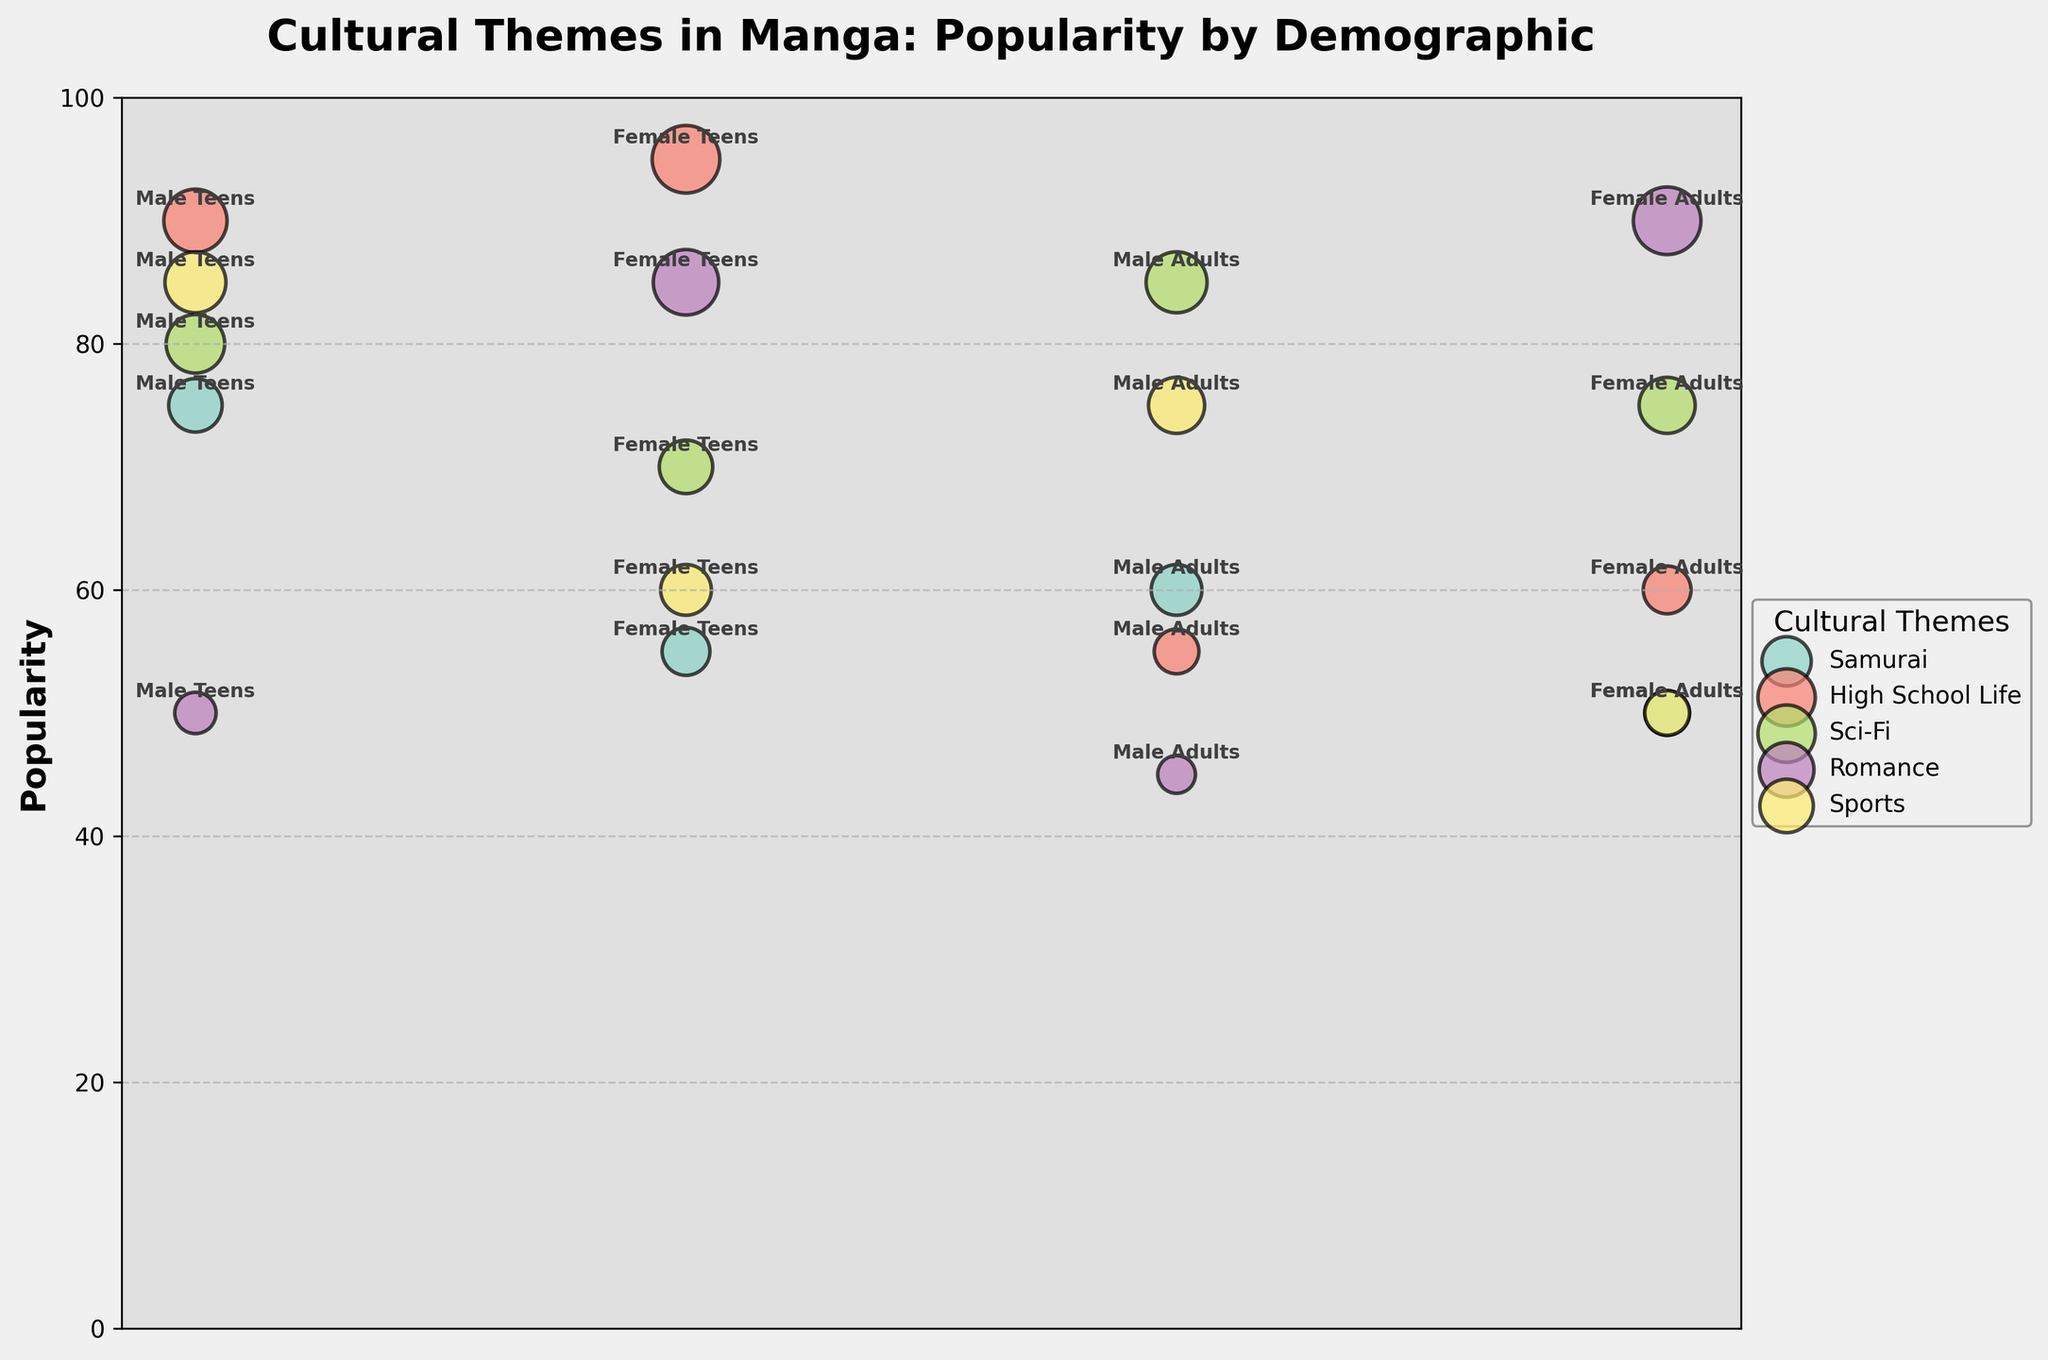What's the most popular theme among Female Teens? From the plot, we can look at the y-axis, which represents popularity, and compare the points labeled "Female Teens". The point with the highest y-value indicates the most popular theme for Female Teens. In this case, it's "High School Life" with a popularity score of 95.
Answer: High School Life Which demographic segment finds Romance the least popular? To answer this, locate all the points labeled "Romance" and identify the one with the lowest y-value (popularity). Among the four segments, Male Adults have the lowest popularity for Romance at 45.
Answer: Male Adults What is the average popularity of the Sci-Fi theme across all demographic segments? Locate all points labeled "Sci-Fi" and sum their y-values, then divide by the number of points. The popularity scores are 80, 70, 85, and 75. The average is (80 + 70 + 85 + 75) / 4 = 77.5.
Answer: 77.5 Comparing Female Teens' interest in High School Life and Sci-Fi, which one is more popular? Look at the y-values of points labeled "Female Teens" for "High School Life" and "Sci-Fi". "High School Life" has a y-value of 95, whereas "Sci-Fi" has a y-value of 70. Hence, "High School Life" is more popular among Female Teens.
Answer: High School Life What's the difference in popularity between Samurai and Sports among Male Teens? Find the points labeled "Male Teens" for "Samurai" and "Sports" and subtract their y-values. The popularity of Samurai is 75, and for Sports, it is 85. The difference is 85 - 75 = 10.
Answer: 10 Which demographic segment shows an above-average interest in Samurai theme? Determine the average popularity of Samurai across all segments (75, 55, 60, 50) and compare each demographic segment's popularity to this average. The average is (75 + 55 + 60 + 50) / 4 = 60. Male Teens (75) and Male Adults (60) are above this average.
Answer: Male Teens and Male Adults How many distinct cultural themes are represented in the chart? Since there are unique colors for each cultural theme, count the distinct colors in the scatter plot. There are five distinct cultural themes: Samurai, High School Life, Sci-Fi, Romance, and Sports.
Answer: 5 What is the total popularity score for High School Life across all adult demographics? Find the y-values for the "High School Life" theme in the adult demographic points and sum them. The values are 55 and 60. The total popularity score is 55 + 60 = 115.
Answer: 115 